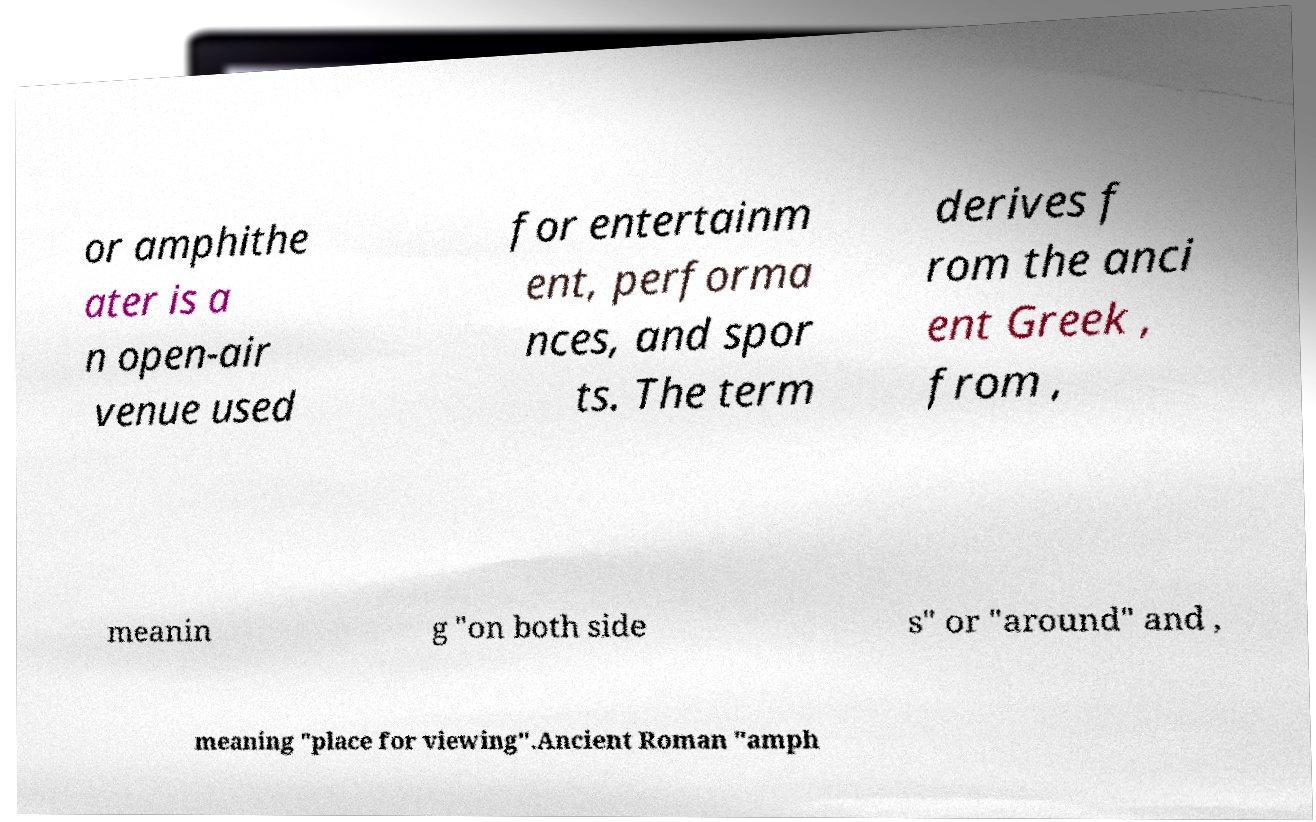Can you accurately transcribe the text from the provided image for me? or amphithe ater is a n open-air venue used for entertainm ent, performa nces, and spor ts. The term derives f rom the anci ent Greek , from , meanin g "on both side s" or "around" and , meaning "place for viewing".Ancient Roman "amph 